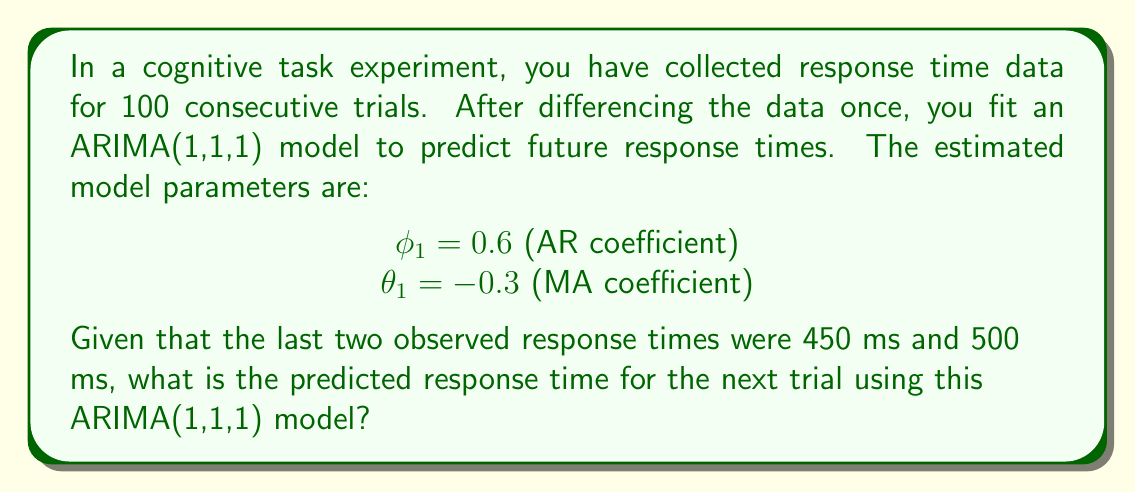Can you solve this math problem? To solve this problem, we need to follow these steps:

1) Recall the general form of an ARIMA(1,1,1) model:
   $$(1-B)(1-\phi_1B)y_t = (1-\theta_1B)\epsilon_t$$
   where $B$ is the backshift operator.

2) Expanding this, we get:
   $$y_t - y_{t-1} = \phi_1(y_{t-1} - y_{t-2}) + \epsilon_t - \theta_1\epsilon_{t-1}$$

3) Rearranging to isolate $y_t$:
   $$y_t = y_{t-1} + \phi_1(y_{t-1} - y_{t-2}) + \epsilon_t - \theta_1\epsilon_{t-1}$$

4) For forecasting one step ahead, we set $\epsilon_t = 0$ (its expected value) and use the most recent error term for $\epsilon_{t-1}$. However, we don't have this value, so we'll also set it to 0.

5) Now, let's plug in our known values:
   $y_{t-1} = 500$ (the last observed response time)
   $y_{t-2} = 450$ (the second-to-last observed response time)
   $\phi_1 = 0.6$
   $\theta_1 = -0.3$

6) Substituting these into our equation:
   $$\hat{y}_t = 500 + 0.6(500 - 450) + 0 - 0 \cdot 0$$

7) Simplifying:
   $$\hat{y}_t = 500 + 0.6(50) = 500 + 30 = 530$$

Therefore, the predicted response time for the next trial is 530 ms.
Answer: 530 ms 